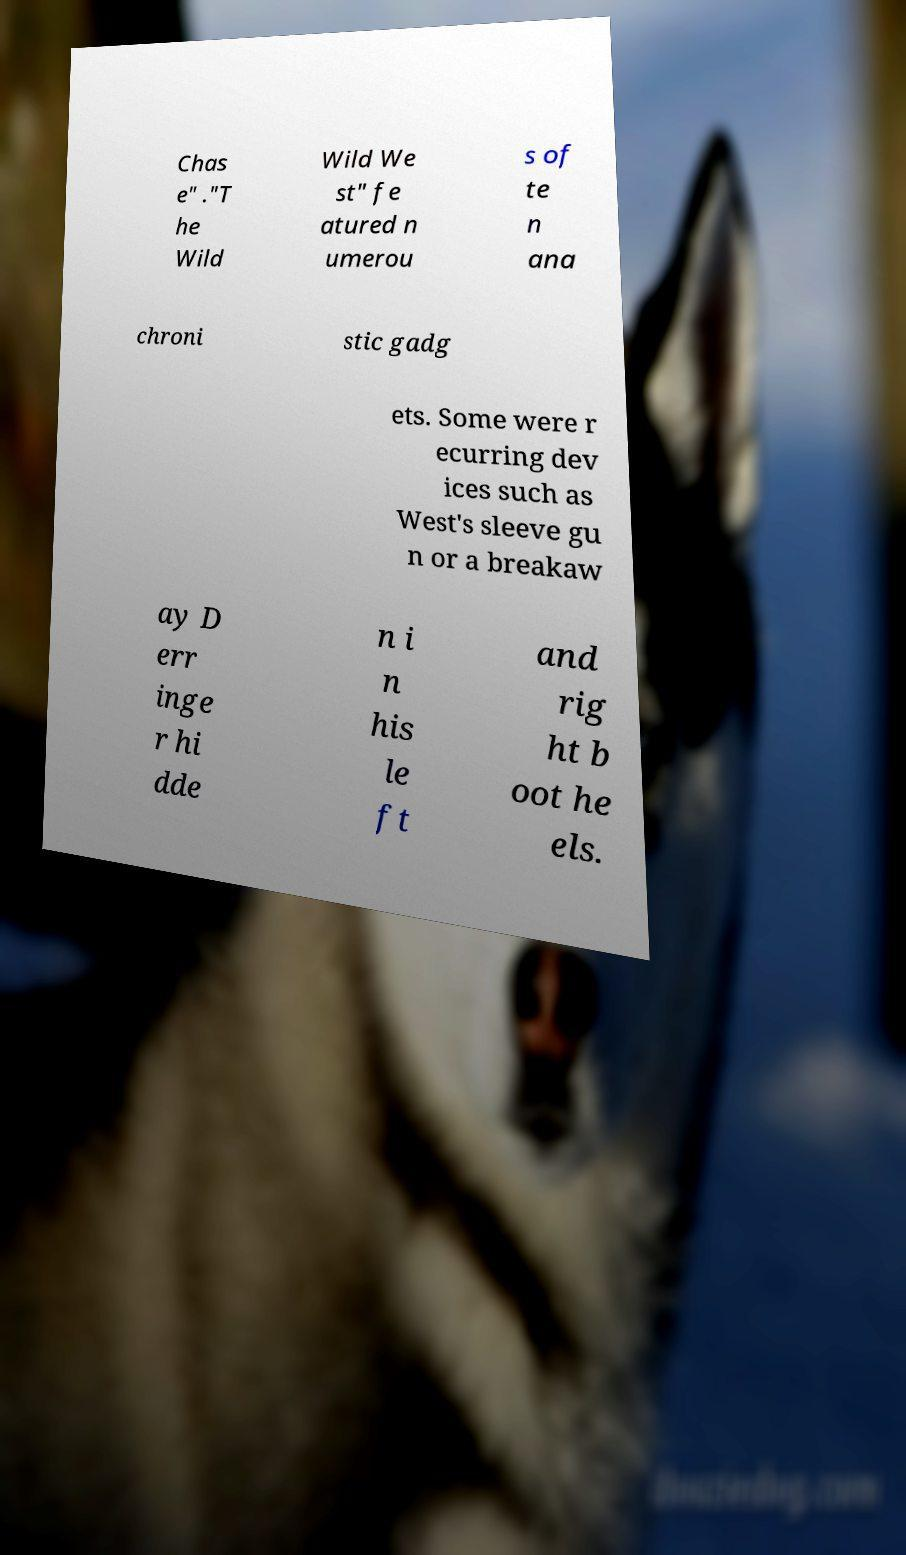Please identify and transcribe the text found in this image. Chas e" ."T he Wild Wild We st" fe atured n umerou s of te n ana chroni stic gadg ets. Some were r ecurring dev ices such as West's sleeve gu n or a breakaw ay D err inge r hi dde n i n his le ft and rig ht b oot he els. 